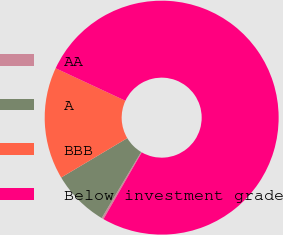Convert chart. <chart><loc_0><loc_0><loc_500><loc_500><pie_chart><fcel>AA<fcel>A<fcel>BBB<fcel>Below investment grade<nl><fcel>0.28%<fcel>7.88%<fcel>15.49%<fcel>76.35%<nl></chart> 